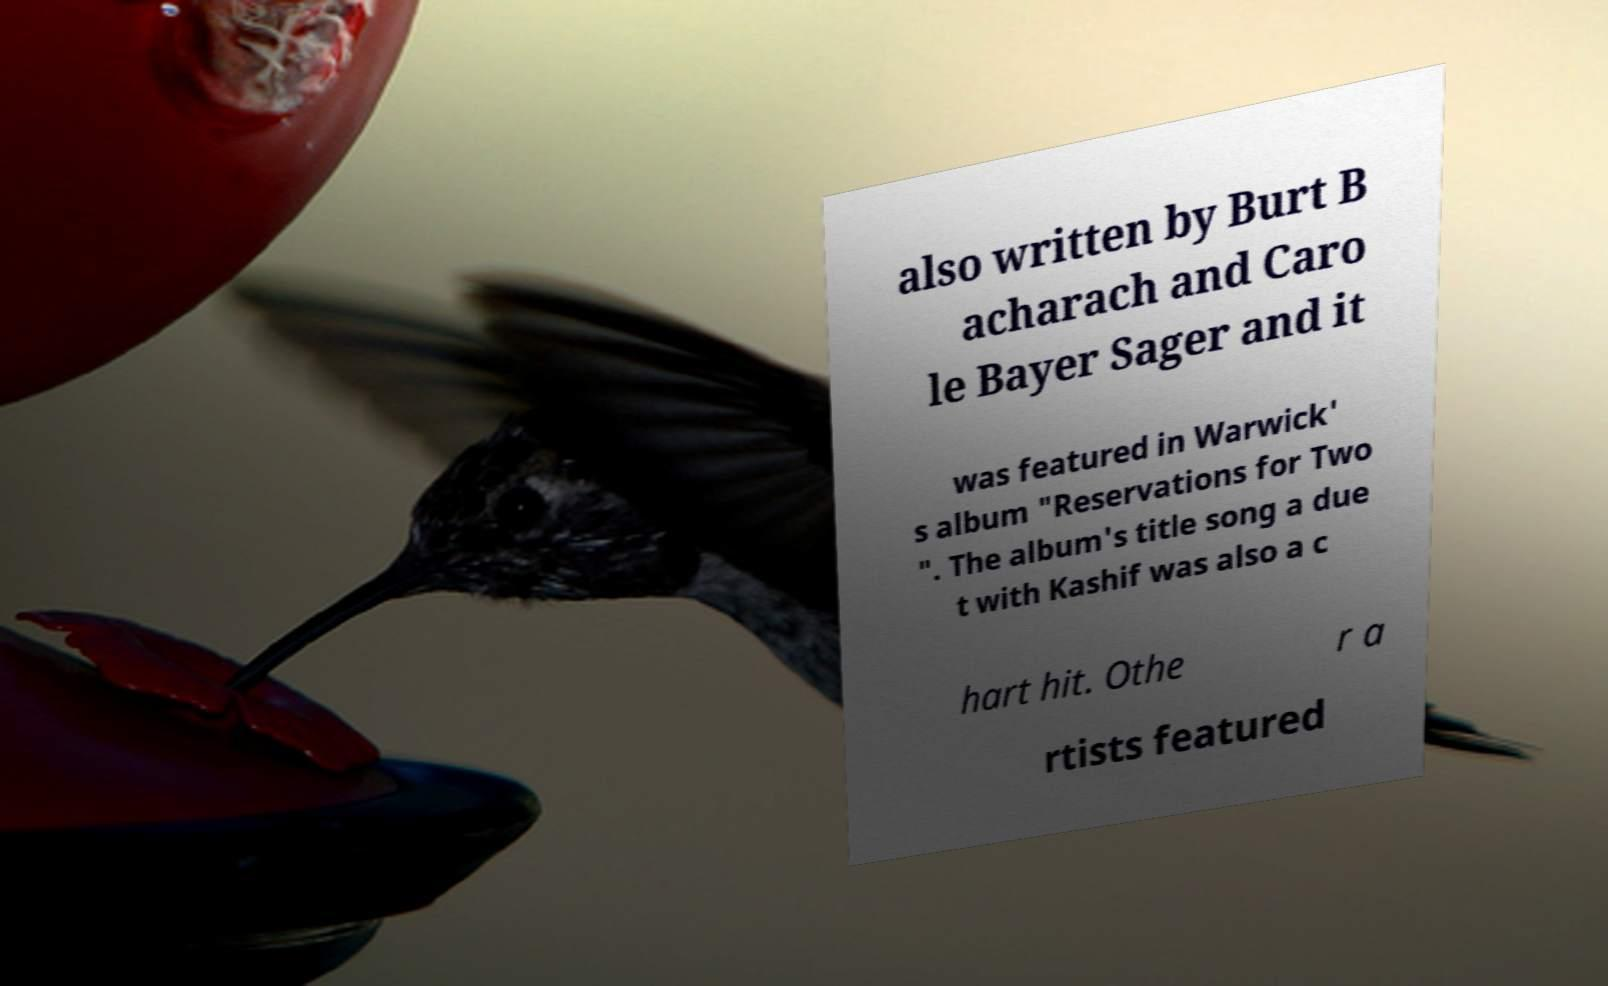Please identify and transcribe the text found in this image. also written by Burt B acharach and Caro le Bayer Sager and it was featured in Warwick' s album "Reservations for Two ". The album's title song a due t with Kashif was also a c hart hit. Othe r a rtists featured 